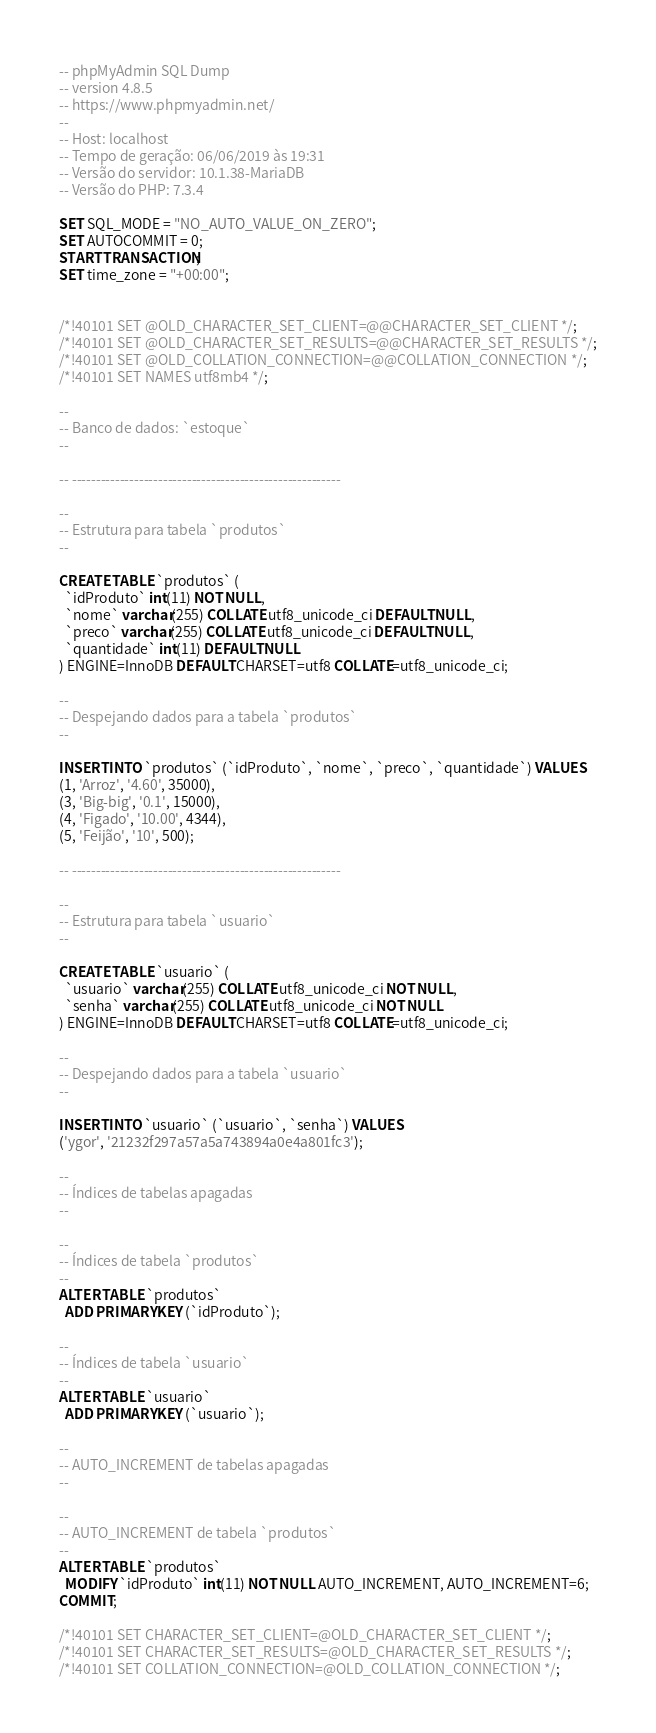<code> <loc_0><loc_0><loc_500><loc_500><_SQL_>-- phpMyAdmin SQL Dump
-- version 4.8.5
-- https://www.phpmyadmin.net/
--
-- Host: localhost
-- Tempo de geração: 06/06/2019 às 19:31
-- Versão do servidor: 10.1.38-MariaDB
-- Versão do PHP: 7.3.4

SET SQL_MODE = "NO_AUTO_VALUE_ON_ZERO";
SET AUTOCOMMIT = 0;
START TRANSACTION;
SET time_zone = "+00:00";


/*!40101 SET @OLD_CHARACTER_SET_CLIENT=@@CHARACTER_SET_CLIENT */;
/*!40101 SET @OLD_CHARACTER_SET_RESULTS=@@CHARACTER_SET_RESULTS */;
/*!40101 SET @OLD_COLLATION_CONNECTION=@@COLLATION_CONNECTION */;
/*!40101 SET NAMES utf8mb4 */;

--
-- Banco de dados: `estoque`
--

-- --------------------------------------------------------

--
-- Estrutura para tabela `produtos`
--

CREATE TABLE `produtos` (
  `idProduto` int(11) NOT NULL,
  `nome` varchar(255) COLLATE utf8_unicode_ci DEFAULT NULL,
  `preco` varchar(255) COLLATE utf8_unicode_ci DEFAULT NULL,
  `quantidade` int(11) DEFAULT NULL
) ENGINE=InnoDB DEFAULT CHARSET=utf8 COLLATE=utf8_unicode_ci;

--
-- Despejando dados para a tabela `produtos`
--

INSERT INTO `produtos` (`idProduto`, `nome`, `preco`, `quantidade`) VALUES
(1, 'Arroz', '4.60', 35000),
(3, 'Big-big', '0.1', 15000),
(4, 'Figado', '10.00', 4344),
(5, 'Feijão', '10', 500);

-- --------------------------------------------------------

--
-- Estrutura para tabela `usuario`
--

CREATE TABLE `usuario` (
  `usuario` varchar(255) COLLATE utf8_unicode_ci NOT NULL,
  `senha` varchar(255) COLLATE utf8_unicode_ci NOT NULL
) ENGINE=InnoDB DEFAULT CHARSET=utf8 COLLATE=utf8_unicode_ci;

--
-- Despejando dados para a tabela `usuario`
--

INSERT INTO `usuario` (`usuario`, `senha`) VALUES
('ygor', '21232f297a57a5a743894a0e4a801fc3');

--
-- Índices de tabelas apagadas
--

--
-- Índices de tabela `produtos`
--
ALTER TABLE `produtos`
  ADD PRIMARY KEY (`idProduto`);

--
-- Índices de tabela `usuario`
--
ALTER TABLE `usuario`
  ADD PRIMARY KEY (`usuario`);

--
-- AUTO_INCREMENT de tabelas apagadas
--

--
-- AUTO_INCREMENT de tabela `produtos`
--
ALTER TABLE `produtos`
  MODIFY `idProduto` int(11) NOT NULL AUTO_INCREMENT, AUTO_INCREMENT=6;
COMMIT;

/*!40101 SET CHARACTER_SET_CLIENT=@OLD_CHARACTER_SET_CLIENT */;
/*!40101 SET CHARACTER_SET_RESULTS=@OLD_CHARACTER_SET_RESULTS */;
/*!40101 SET COLLATION_CONNECTION=@OLD_COLLATION_CONNECTION */;
</code> 